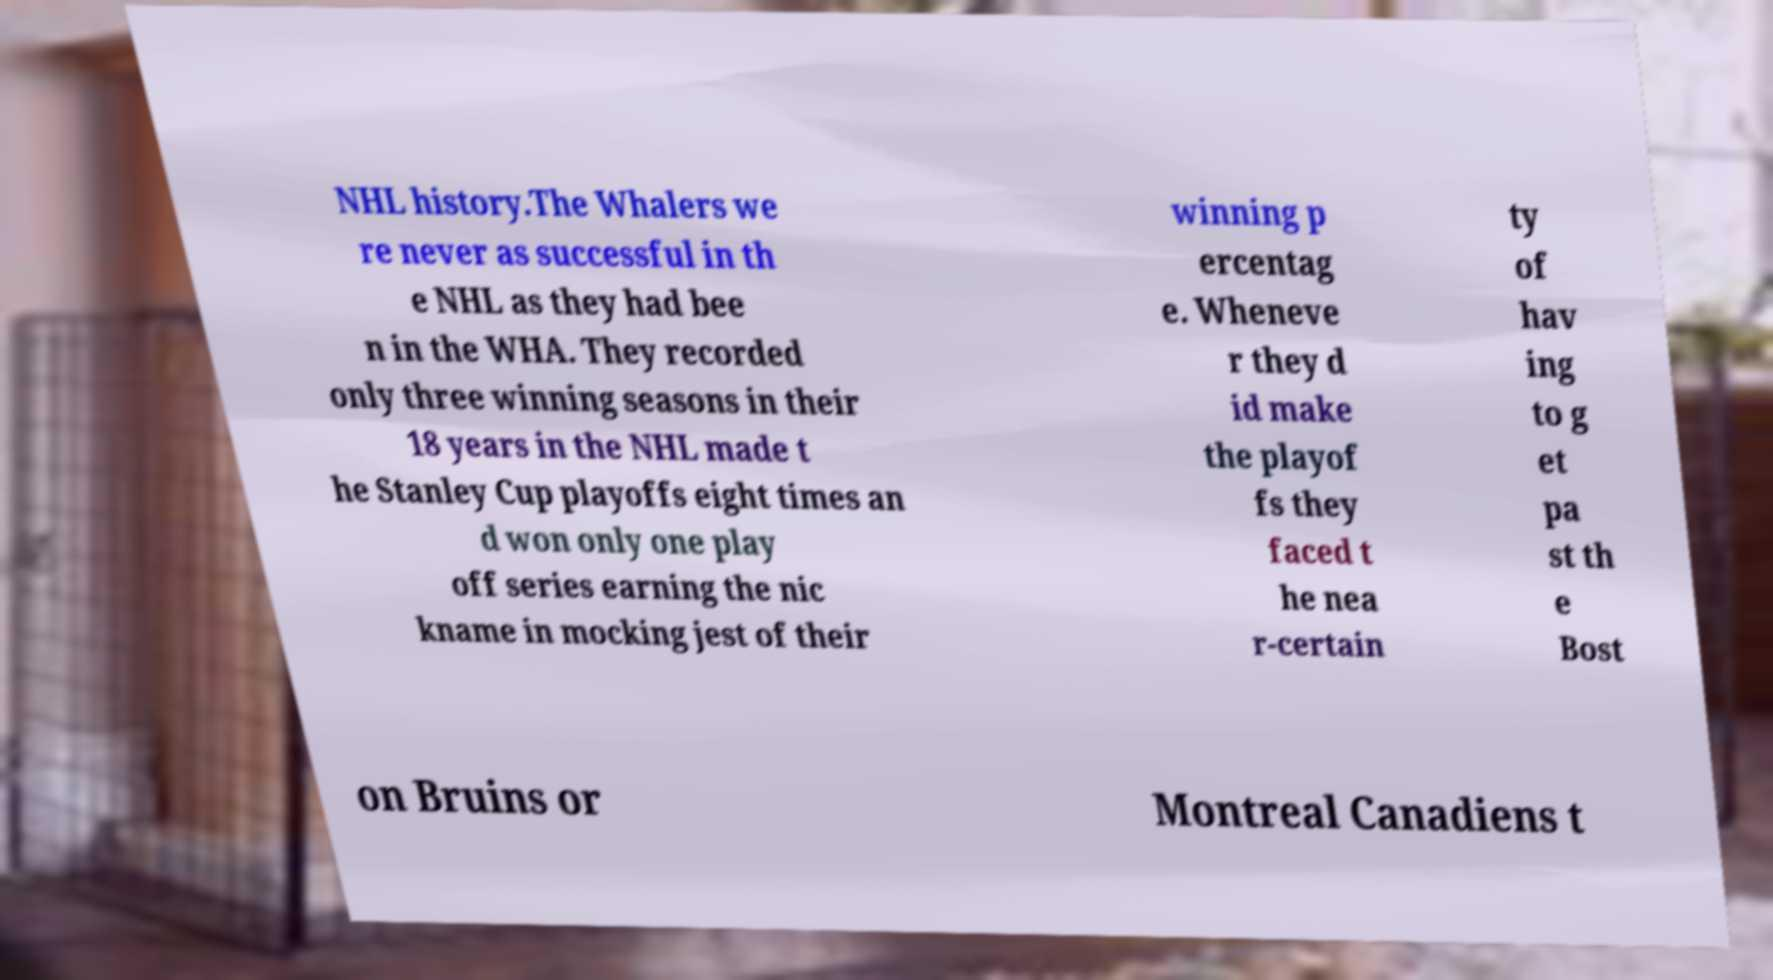Can you read and provide the text displayed in the image?This photo seems to have some interesting text. Can you extract and type it out for me? NHL history.The Whalers we re never as successful in th e NHL as they had bee n in the WHA. They recorded only three winning seasons in their 18 years in the NHL made t he Stanley Cup playoffs eight times an d won only one play off series earning the nic kname in mocking jest of their winning p ercentag e. Wheneve r they d id make the playof fs they faced t he nea r-certain ty of hav ing to g et pa st th e Bost on Bruins or Montreal Canadiens t 